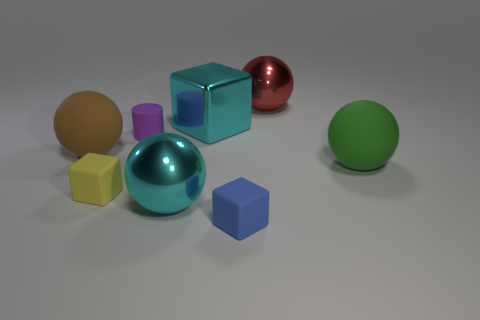Is there any other thing that has the same color as the cylinder?
Keep it short and to the point. No. The big rubber sphere on the left side of the cyan shiny thing that is in front of the metal cube is what color?
Your answer should be very brief. Brown. Is the size of the rubber cylinder the same as the brown sphere?
Your response must be concise. No. Does the thing that is on the right side of the big red thing have the same material as the big cube behind the large cyan metal ball?
Give a very brief answer. No. What is the shape of the big metal object that is right of the tiny matte cube that is in front of the cyan object in front of the matte cylinder?
Offer a very short reply. Sphere. Is the number of big metal things greater than the number of cyan metallic objects?
Offer a terse response. Yes. Is there a tiny red metallic cylinder?
Make the answer very short. No. What number of things are either rubber things in front of the brown rubber object or small blocks right of the purple rubber cylinder?
Give a very brief answer. 3. Is the color of the cylinder the same as the metallic cube?
Your response must be concise. No. Are there fewer big cyan balls than small things?
Provide a short and direct response. Yes. 